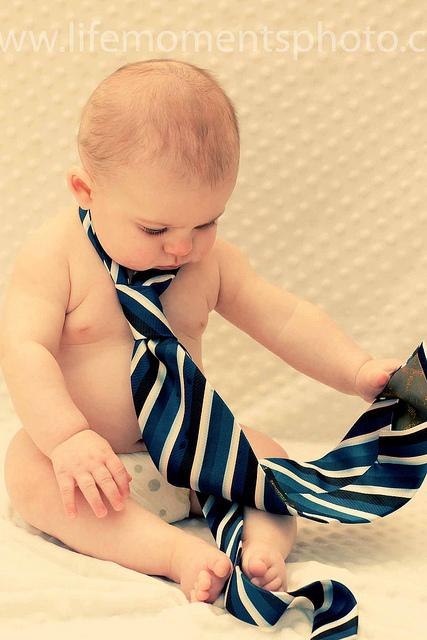Is this baby wearing baby clothes?
Keep it brief. No. What is the baby sitting on?
Give a very brief answer. Blanket. What is the watermark on this photo?
Keep it brief. Wwwlife moments photocom. 